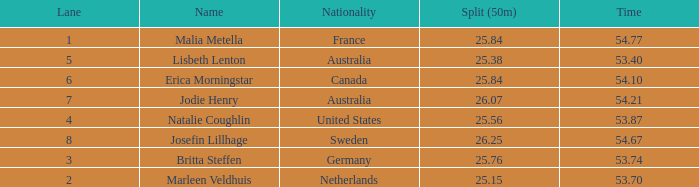What is the total sum of 50m splits for josefin lillhage in lanes above 8? None. Can you give me this table as a dict? {'header': ['Lane', 'Name', 'Nationality', 'Split (50m)', 'Time'], 'rows': [['1', 'Malia Metella', 'France', '25.84', '54.77'], ['5', 'Lisbeth Lenton', 'Australia', '25.38', '53.40'], ['6', 'Erica Morningstar', 'Canada', '25.84', '54.10'], ['7', 'Jodie Henry', 'Australia', '26.07', '54.21'], ['4', 'Natalie Coughlin', 'United States', '25.56', '53.87'], ['8', 'Josefin Lillhage', 'Sweden', '26.25', '54.67'], ['3', 'Britta Steffen', 'Germany', '25.76', '53.74'], ['2', 'Marleen Veldhuis', 'Netherlands', '25.15', '53.70']]} 